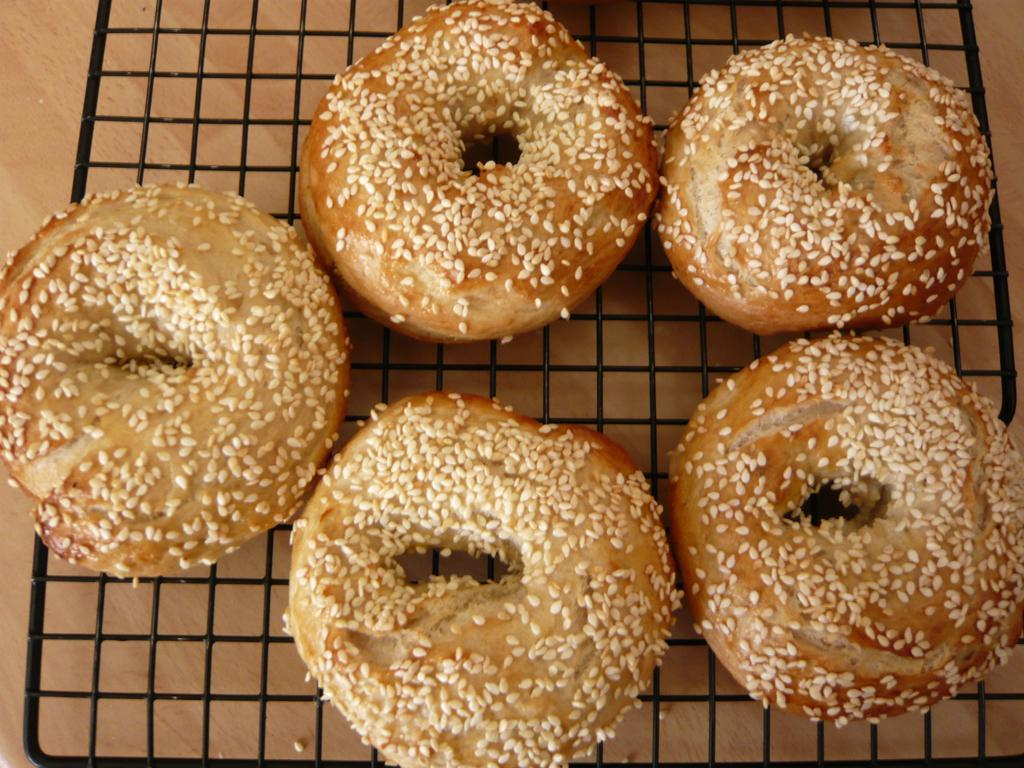What type of food is being cooked in the image? There are donuts on a grill in the image. Where are the donuts located in the image? The donuts are in the center of the image. What is the limit of the bag in the image? There is no bag present in the image, so it is not possible to determine a limit. 